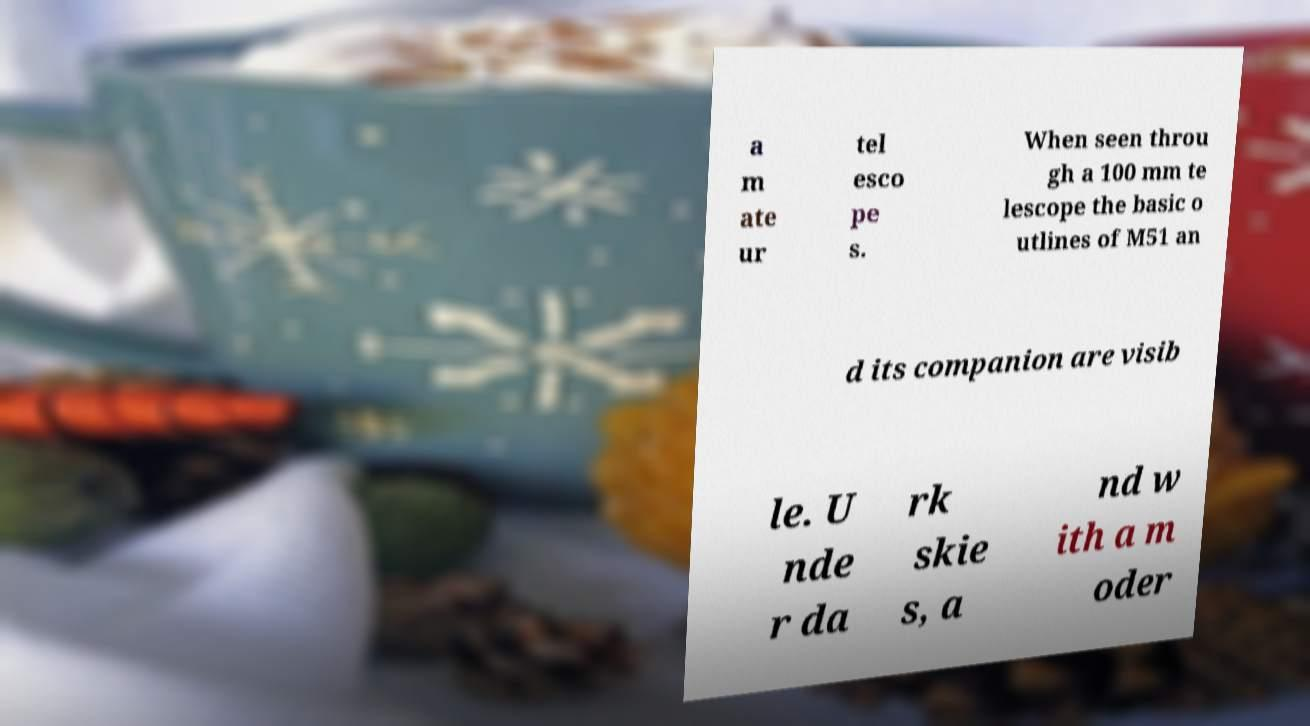Please identify and transcribe the text found in this image. a m ate ur tel esco pe s. When seen throu gh a 100 mm te lescope the basic o utlines of M51 an d its companion are visib le. U nde r da rk skie s, a nd w ith a m oder 